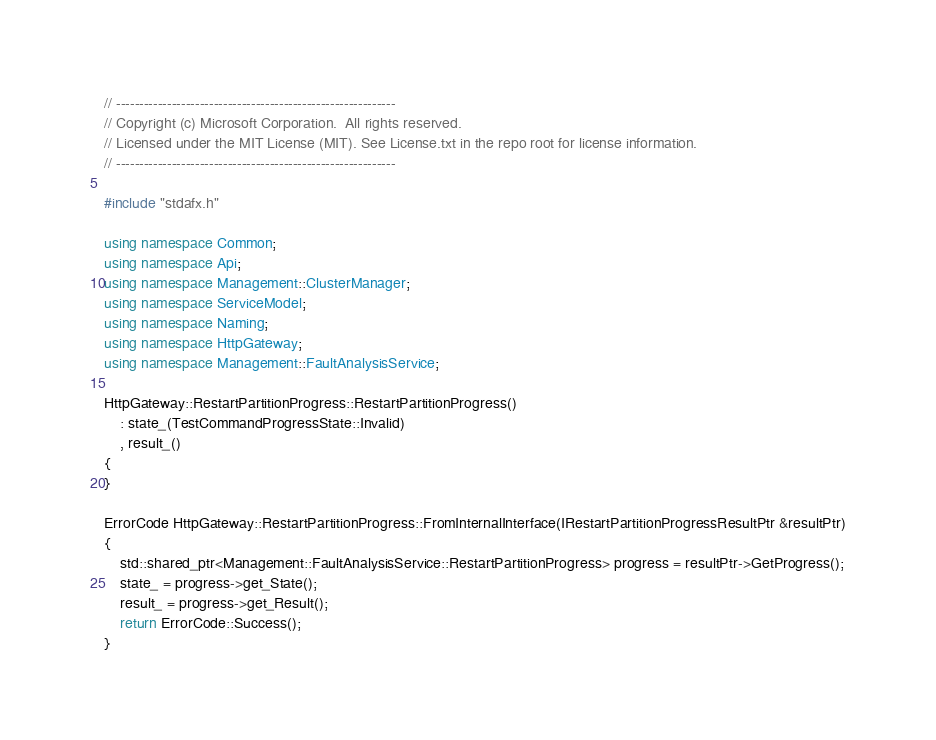<code> <loc_0><loc_0><loc_500><loc_500><_C++_>// ------------------------------------------------------------
// Copyright (c) Microsoft Corporation.  All rights reserved.
// Licensed under the MIT License (MIT). See License.txt in the repo root for license information.
// ------------------------------------------------------------

#include "stdafx.h"

using namespace Common;
using namespace Api;
using namespace Management::ClusterManager;
using namespace ServiceModel;
using namespace Naming;
using namespace HttpGateway;
using namespace Management::FaultAnalysisService;

HttpGateway::RestartPartitionProgress::RestartPartitionProgress()
    : state_(TestCommandProgressState::Invalid)
    , result_()   
{
}

ErrorCode HttpGateway::RestartPartitionProgress::FromInternalInterface(IRestartPartitionProgressResultPtr &resultPtr)
{
    std::shared_ptr<Management::FaultAnalysisService::RestartPartitionProgress> progress = resultPtr->GetProgress();
    state_ = progress->get_State();
    result_ = progress->get_Result();
    return ErrorCode::Success();
}
</code> 